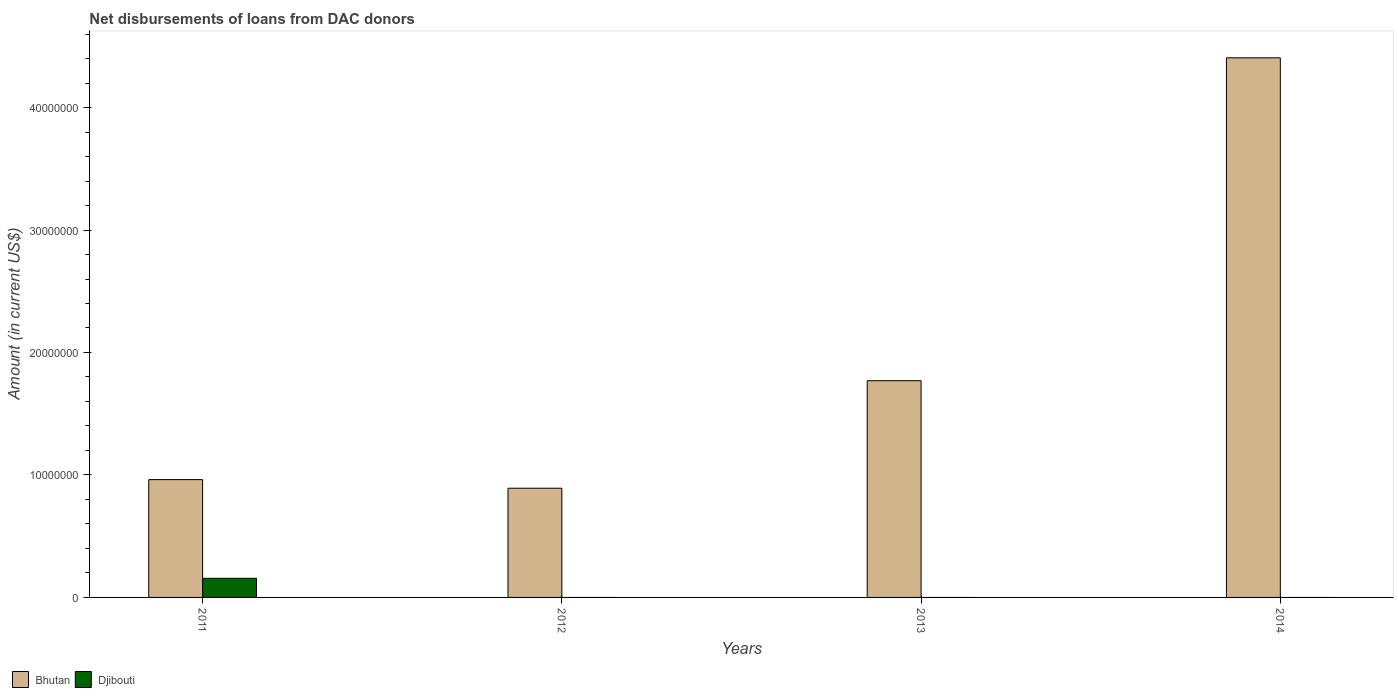Are the number of bars per tick equal to the number of legend labels?
Your response must be concise. No. Are the number of bars on each tick of the X-axis equal?
Ensure brevity in your answer.  No. How many bars are there on the 3rd tick from the left?
Your answer should be very brief. 1. How many bars are there on the 3rd tick from the right?
Offer a terse response. 1. What is the amount of loans disbursed in Bhutan in 2014?
Offer a terse response. 4.41e+07. Across all years, what is the maximum amount of loans disbursed in Bhutan?
Offer a very short reply. 4.41e+07. Across all years, what is the minimum amount of loans disbursed in Bhutan?
Give a very brief answer. 8.92e+06. What is the total amount of loans disbursed in Djibouti in the graph?
Ensure brevity in your answer.  1.56e+06. What is the difference between the amount of loans disbursed in Bhutan in 2011 and that in 2014?
Offer a very short reply. -3.44e+07. What is the difference between the amount of loans disbursed in Djibouti in 2012 and the amount of loans disbursed in Bhutan in 2013?
Your response must be concise. -1.77e+07. What is the average amount of loans disbursed in Bhutan per year?
Provide a short and direct response. 2.01e+07. In the year 2011, what is the difference between the amount of loans disbursed in Djibouti and amount of loans disbursed in Bhutan?
Your answer should be compact. -8.06e+06. What is the ratio of the amount of loans disbursed in Bhutan in 2012 to that in 2013?
Keep it short and to the point. 0.5. Is the amount of loans disbursed in Bhutan in 2011 less than that in 2012?
Provide a short and direct response. No. What is the difference between the highest and the second highest amount of loans disbursed in Bhutan?
Ensure brevity in your answer.  2.64e+07. What is the difference between the highest and the lowest amount of loans disbursed in Djibouti?
Your response must be concise. 1.56e+06. In how many years, is the amount of loans disbursed in Djibouti greater than the average amount of loans disbursed in Djibouti taken over all years?
Your answer should be compact. 1. How many bars are there?
Provide a succinct answer. 5. Are all the bars in the graph horizontal?
Offer a terse response. No. What is the difference between two consecutive major ticks on the Y-axis?
Give a very brief answer. 1.00e+07. Are the values on the major ticks of Y-axis written in scientific E-notation?
Your response must be concise. No. Does the graph contain any zero values?
Your answer should be very brief. Yes. Does the graph contain grids?
Give a very brief answer. No. Where does the legend appear in the graph?
Your answer should be very brief. Bottom left. How many legend labels are there?
Make the answer very short. 2. How are the legend labels stacked?
Provide a succinct answer. Horizontal. What is the title of the graph?
Give a very brief answer. Net disbursements of loans from DAC donors. Does "Iraq" appear as one of the legend labels in the graph?
Your answer should be compact. No. What is the label or title of the Y-axis?
Offer a very short reply. Amount (in current US$). What is the Amount (in current US$) in Bhutan in 2011?
Give a very brief answer. 9.62e+06. What is the Amount (in current US$) of Djibouti in 2011?
Make the answer very short. 1.56e+06. What is the Amount (in current US$) of Bhutan in 2012?
Offer a very short reply. 8.92e+06. What is the Amount (in current US$) of Djibouti in 2012?
Ensure brevity in your answer.  0. What is the Amount (in current US$) of Bhutan in 2013?
Keep it short and to the point. 1.77e+07. What is the Amount (in current US$) in Bhutan in 2014?
Your answer should be very brief. 4.41e+07. What is the Amount (in current US$) of Djibouti in 2014?
Keep it short and to the point. 0. Across all years, what is the maximum Amount (in current US$) of Bhutan?
Your response must be concise. 4.41e+07. Across all years, what is the maximum Amount (in current US$) in Djibouti?
Make the answer very short. 1.56e+06. Across all years, what is the minimum Amount (in current US$) in Bhutan?
Offer a terse response. 8.92e+06. Across all years, what is the minimum Amount (in current US$) in Djibouti?
Your answer should be compact. 0. What is the total Amount (in current US$) in Bhutan in the graph?
Provide a short and direct response. 8.03e+07. What is the total Amount (in current US$) in Djibouti in the graph?
Offer a very short reply. 1.56e+06. What is the difference between the Amount (in current US$) of Bhutan in 2011 and that in 2012?
Your response must be concise. 7.03e+05. What is the difference between the Amount (in current US$) in Bhutan in 2011 and that in 2013?
Your response must be concise. -8.08e+06. What is the difference between the Amount (in current US$) in Bhutan in 2011 and that in 2014?
Offer a terse response. -3.44e+07. What is the difference between the Amount (in current US$) in Bhutan in 2012 and that in 2013?
Your response must be concise. -8.78e+06. What is the difference between the Amount (in current US$) of Bhutan in 2012 and that in 2014?
Ensure brevity in your answer.  -3.51e+07. What is the difference between the Amount (in current US$) in Bhutan in 2013 and that in 2014?
Make the answer very short. -2.64e+07. What is the average Amount (in current US$) of Bhutan per year?
Provide a succinct answer. 2.01e+07. What is the average Amount (in current US$) of Djibouti per year?
Make the answer very short. 3.90e+05. In the year 2011, what is the difference between the Amount (in current US$) in Bhutan and Amount (in current US$) in Djibouti?
Your response must be concise. 8.06e+06. What is the ratio of the Amount (in current US$) of Bhutan in 2011 to that in 2012?
Offer a very short reply. 1.08. What is the ratio of the Amount (in current US$) of Bhutan in 2011 to that in 2013?
Offer a terse response. 0.54. What is the ratio of the Amount (in current US$) of Bhutan in 2011 to that in 2014?
Give a very brief answer. 0.22. What is the ratio of the Amount (in current US$) in Bhutan in 2012 to that in 2013?
Provide a succinct answer. 0.5. What is the ratio of the Amount (in current US$) of Bhutan in 2012 to that in 2014?
Make the answer very short. 0.2. What is the ratio of the Amount (in current US$) of Bhutan in 2013 to that in 2014?
Make the answer very short. 0.4. What is the difference between the highest and the second highest Amount (in current US$) of Bhutan?
Give a very brief answer. 2.64e+07. What is the difference between the highest and the lowest Amount (in current US$) of Bhutan?
Your answer should be very brief. 3.51e+07. What is the difference between the highest and the lowest Amount (in current US$) of Djibouti?
Ensure brevity in your answer.  1.56e+06. 